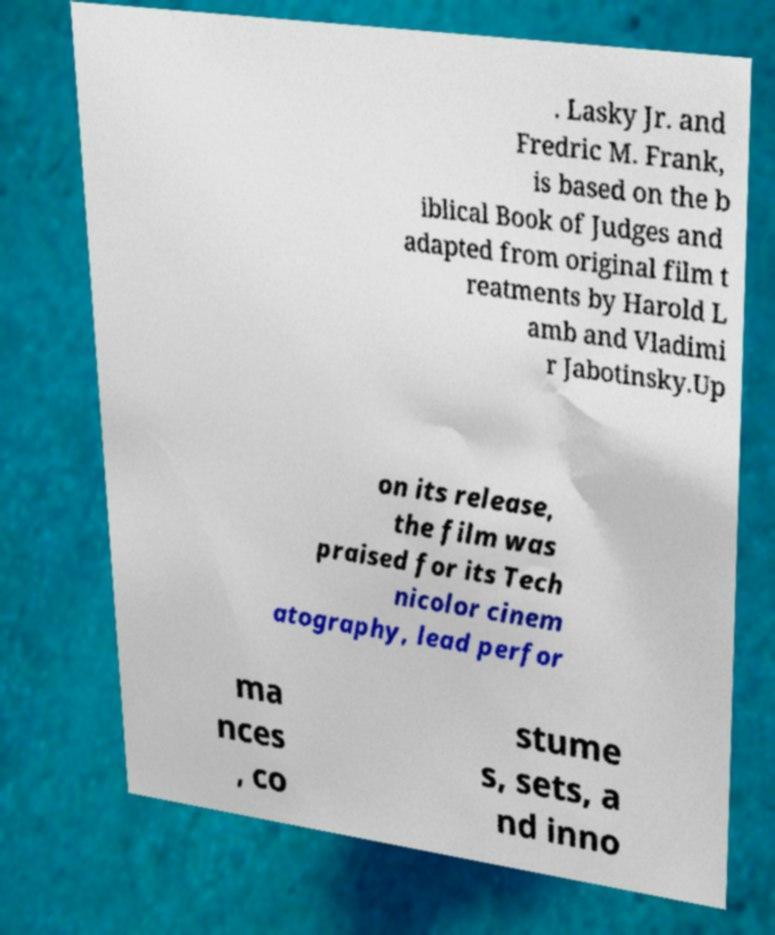There's text embedded in this image that I need extracted. Can you transcribe it verbatim? . Lasky Jr. and Fredric M. Frank, is based on the b iblical Book of Judges and adapted from original film t reatments by Harold L amb and Vladimi r Jabotinsky.Up on its release, the film was praised for its Tech nicolor cinem atography, lead perfor ma nces , co stume s, sets, a nd inno 